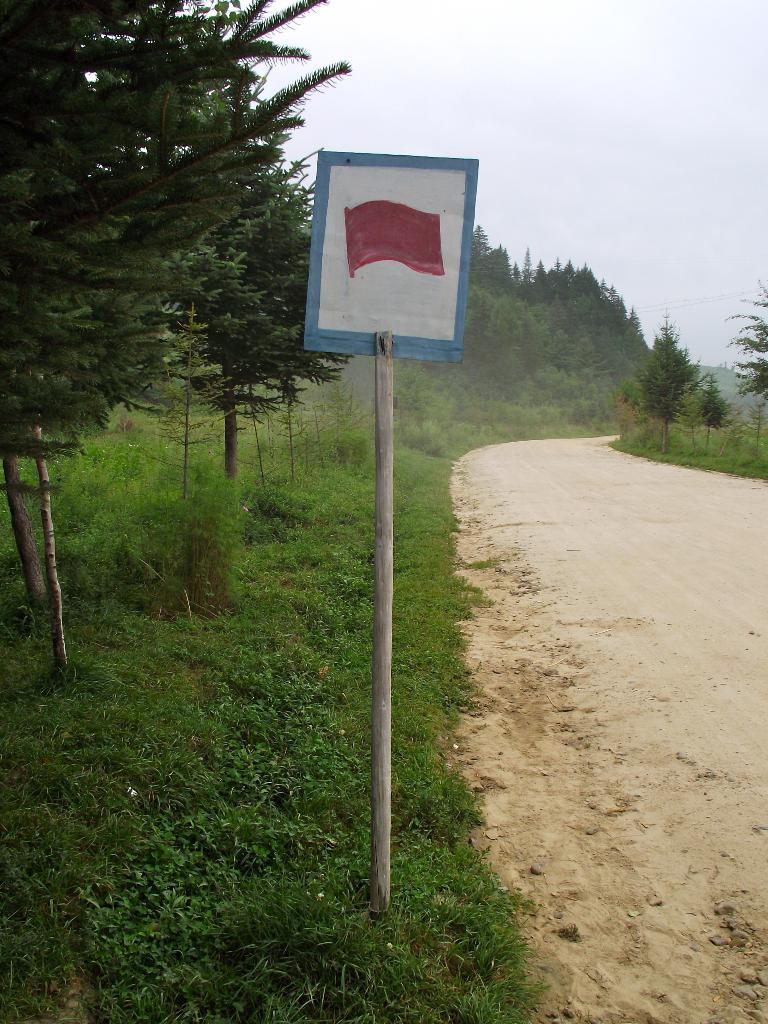Can you describe this image briefly? On the right side of the image there is a road. On the left side of the image on the ground there is grass and there are trees and a pole with board. In the background there are trees. At the top of the image there is sky. 